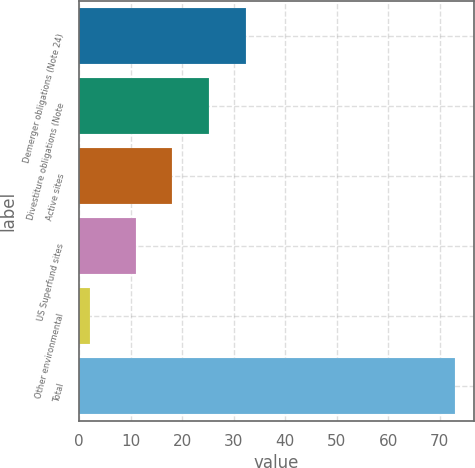Convert chart to OTSL. <chart><loc_0><loc_0><loc_500><loc_500><bar_chart><fcel>Demerger obligations (Note 24)<fcel>Divestiture obligations (Note<fcel>Active sites<fcel>US Superfund sites<fcel>Other environmental<fcel>Total<nl><fcel>32.3<fcel>25.2<fcel>18.1<fcel>11<fcel>2<fcel>73<nl></chart> 